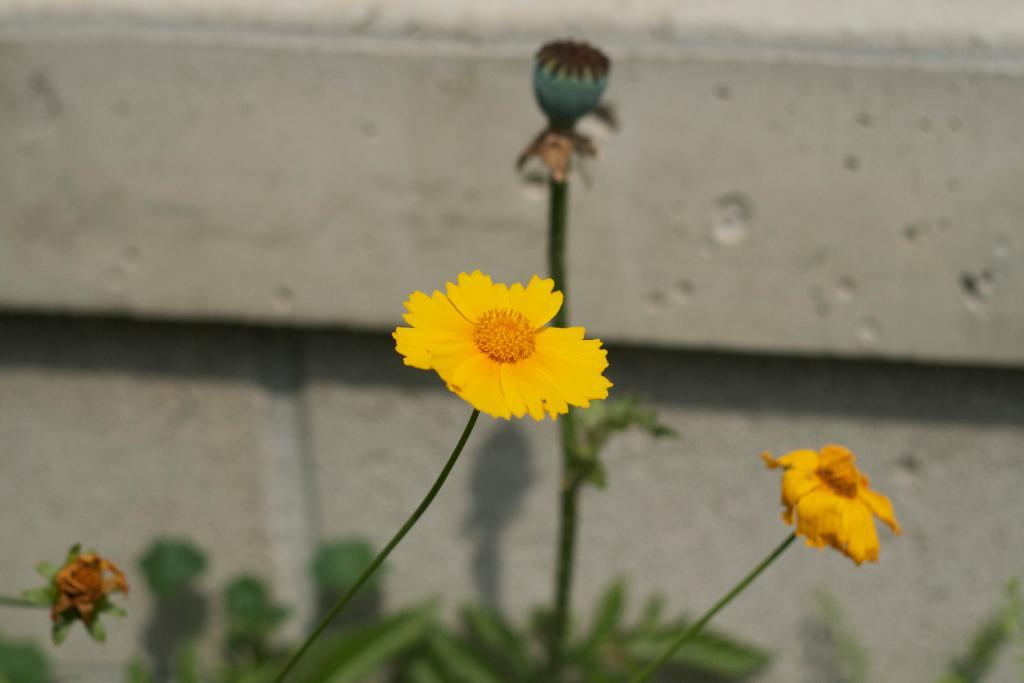What type of flowers can be seen in the image? There are yellow color flowers in the image. What stage of growth are some of the flowers in? There are buds in the image. What else can be seen on the plants besides flowers? There are leaves of the plant in the image. What is behind the plants in the image? There is a wall behind the plants in the image. How would you describe the background of the image? The background of the image is blurred. How does the plant increase its height in the image? The plant does not increase its height in the image; it is a static representation of the plant at a certain stage of growth. 